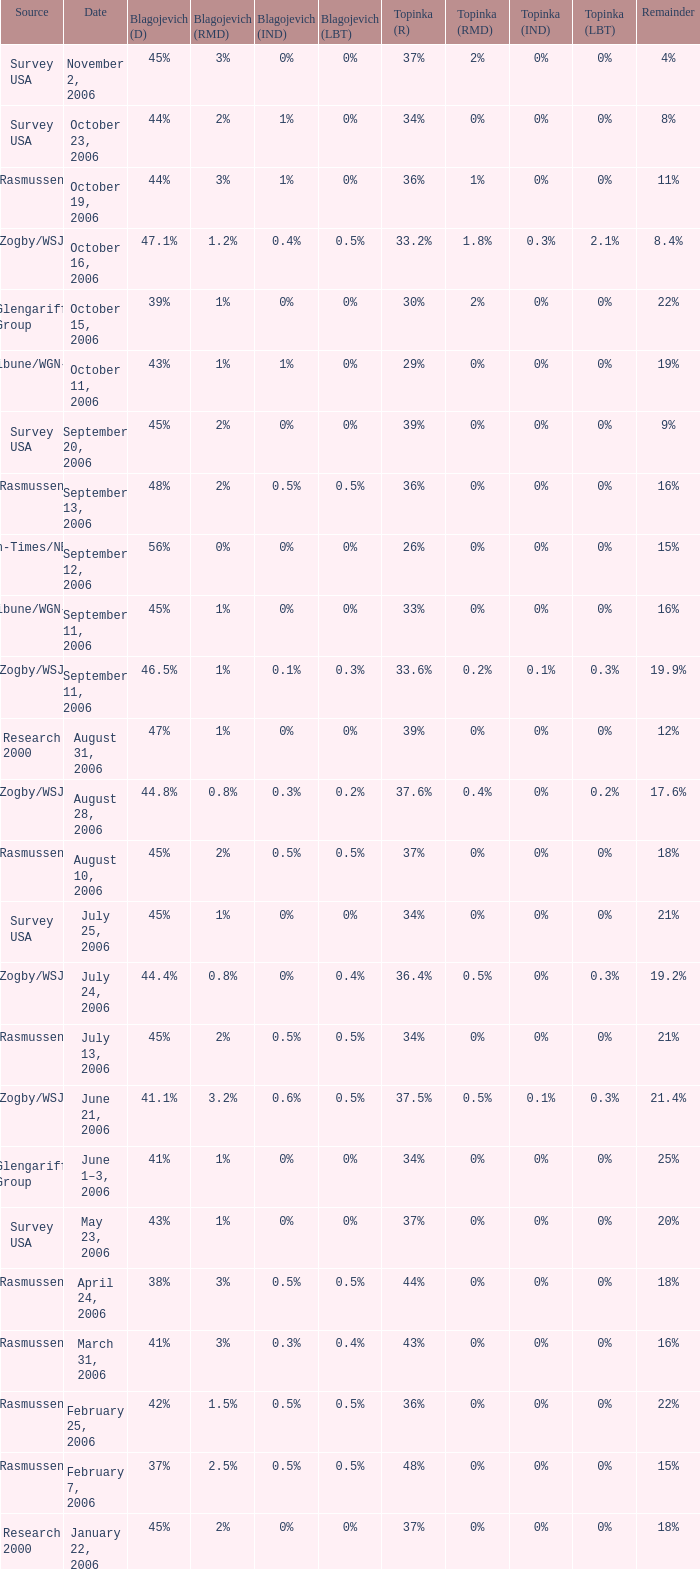Can you parse all the data within this table? {'header': ['Source', 'Date', 'Blagojevich (D)', 'Blagojevich (RMD)', 'Blagojevich (IND)', 'Blagojevich (LBT)', 'Topinka (R)', 'Topinka (RMD)', 'Topinka (IND)', 'Topinka (LBT)', 'Remainder'], 'rows': [['Survey USA', 'November 2, 2006', '45%', '3%', '0%', '0%', '37%', '2%', '0%', '0%', '4%'], ['Survey USA', 'October 23, 2006', '44%', '2%', '1%', '0%', '34%', '0%', '0%', '0%', '8%'], ['Rasmussen', 'October 19, 2006', '44%', '3%', '1%', '0%', '36%', '1%', '0%', '0%', '11%'], ['Zogby/WSJ', 'October 16, 2006', '47.1%', '1.2%', '0.4%', '0.5%', '33.2%', '1.8%', '0.3%', '2.1%', '8.4%'], ['Glengariff Group', 'October 15, 2006', '39%', '1%', '0%', '0%', '30%', '2%', '0%', '0%', '22%'], ['Tribune/WGN-TV', 'October 11, 2006', '43%', '1%', '1%', '0%', '29%', '0%', '0%', '0%', '19%'], ['Survey USA', 'September 20, 2006', '45%', '2%', '0%', '0%', '39%', '0%', '0%', '0%', '9%'], ['Rasmussen', 'September 13, 2006', '48%', '2%', '0.5%', '0.5%', '36%', '0%', '0%', '0%', '16%'], ['Sun-Times/NBC5', 'September 12, 2006', '56%', '0%', '0%', '0%', '26%', '0%', '0%', '0%', '15%'], ['Tribune/WGN-TV', 'September 11, 2006', '45%', '1%', '0%', '0%', '33%', '0%', '0%', '0%', '16%'], ['Zogby/WSJ', 'September 11, 2006', '46.5%', '1%', '0.1%', '0.3%', '33.6%', '0.2%', '0.1%', '0.3%', '19.9%'], ['Research 2000', 'August 31, 2006', '47%', '1%', '0%', '0%', '39%', '0%', '0%', '0%', '12%'], ['Zogby/WSJ', 'August 28, 2006', '44.8%', '0.8%', '0.3%', '0.2%', '37.6%', '0.4%', '0%', '0.2%', '17.6%'], ['Rasmussen', 'August 10, 2006', '45%', '2%', '0.5%', '0.5%', '37%', '0%', '0%', '0%', '18%'], ['Survey USA', 'July 25, 2006', '45%', '1%', '0%', '0%', '34%', '0%', '0%', '0%', '21%'], ['Zogby/WSJ', 'July 24, 2006', '44.4%', '0.8%', '0%', '0.4%', '36.4%', '0.5%', '0%', '0.3%', '19.2%'], ['Rasmussen', 'July 13, 2006', '45%', '2%', '0.5%', '0.5%', '34%', '0%', '0%', '0%', '21%'], ['Zogby/WSJ', 'June 21, 2006', '41.1%', '3.2%', '0.6%', '0.5%', '37.5%', '0.5%', '0.1%', '0.3%', '21.4%'], ['Glengariff Group', 'June 1–3, 2006', '41%', '1%', '0%', '0%', '34%', '0%', '0%', '0%', '25%'], ['Survey USA', 'May 23, 2006', '43%', '1%', '0%', '0%', '37%', '0%', '0%', '0%', '20%'], ['Rasmussen', 'April 24, 2006', '38%', '3%', '0.5%', '0.5%', '44%', '0%', '0%', '0%', '18%'], ['Rasmussen', 'March 31, 2006', '41%', '3%', '0.3%', '0.4%', '43%', '0%', '0%', '0%', '16%'], ['Rasmussen', 'February 25, 2006', '42%', '1.5%', '0.5%', '0.5%', '36%', '0%', '0%', '0%', '22%'], ['Rasmussen', 'February 7, 2006', '37%', '2.5%', '0.5%', '0.5%', '48%', '0%', '0%', '0%', '15%'], ['Research 2000', 'January 22, 2006', '45%', '2%', '0%', '0%', '37%', '0%', '0%', '0%', '18%']]} Which Date has a Remainder of 20%? May 23, 2006. 